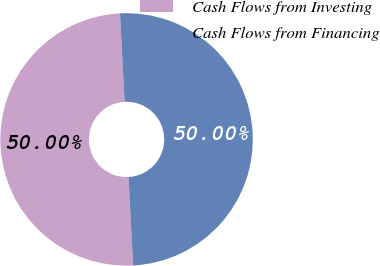Convert chart to OTSL. <chart><loc_0><loc_0><loc_500><loc_500><pie_chart><fcel>Cash Flows from Investing<fcel>Cash Flows from Financing<nl><fcel>50.0%<fcel>50.0%<nl></chart> 